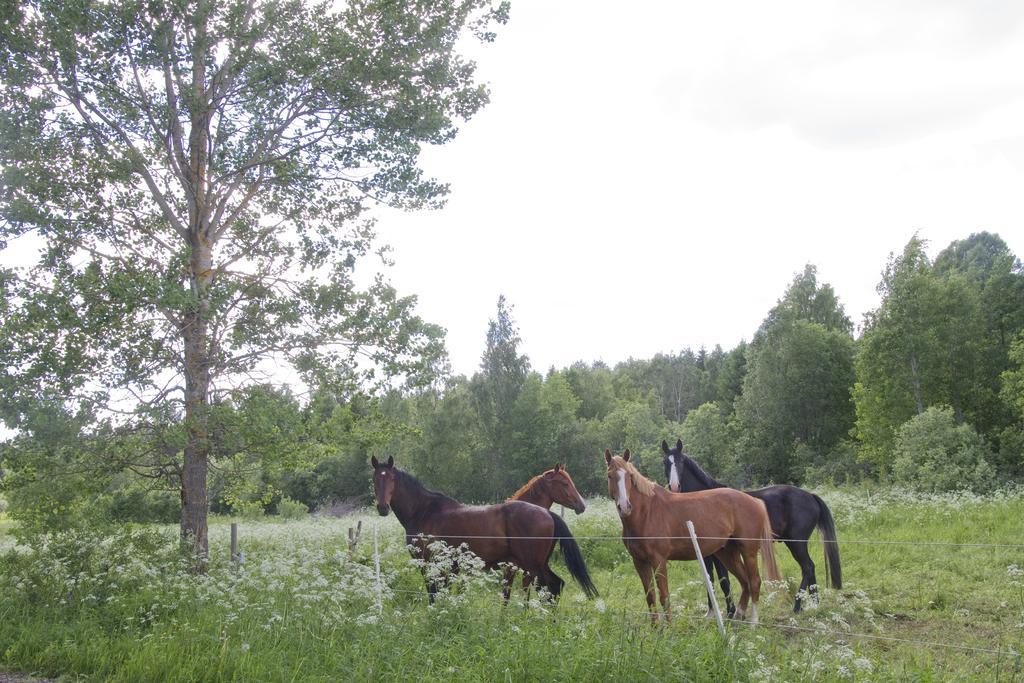Describe this image in one or two sentences. In the picture we can see a grass surface with plants and flowers to it and behind it we can see four horses are standing, three are brown in color and one is black in color and beside it we can see a tree and in the background we can see full of trees and on the top of it we can see the sky. 